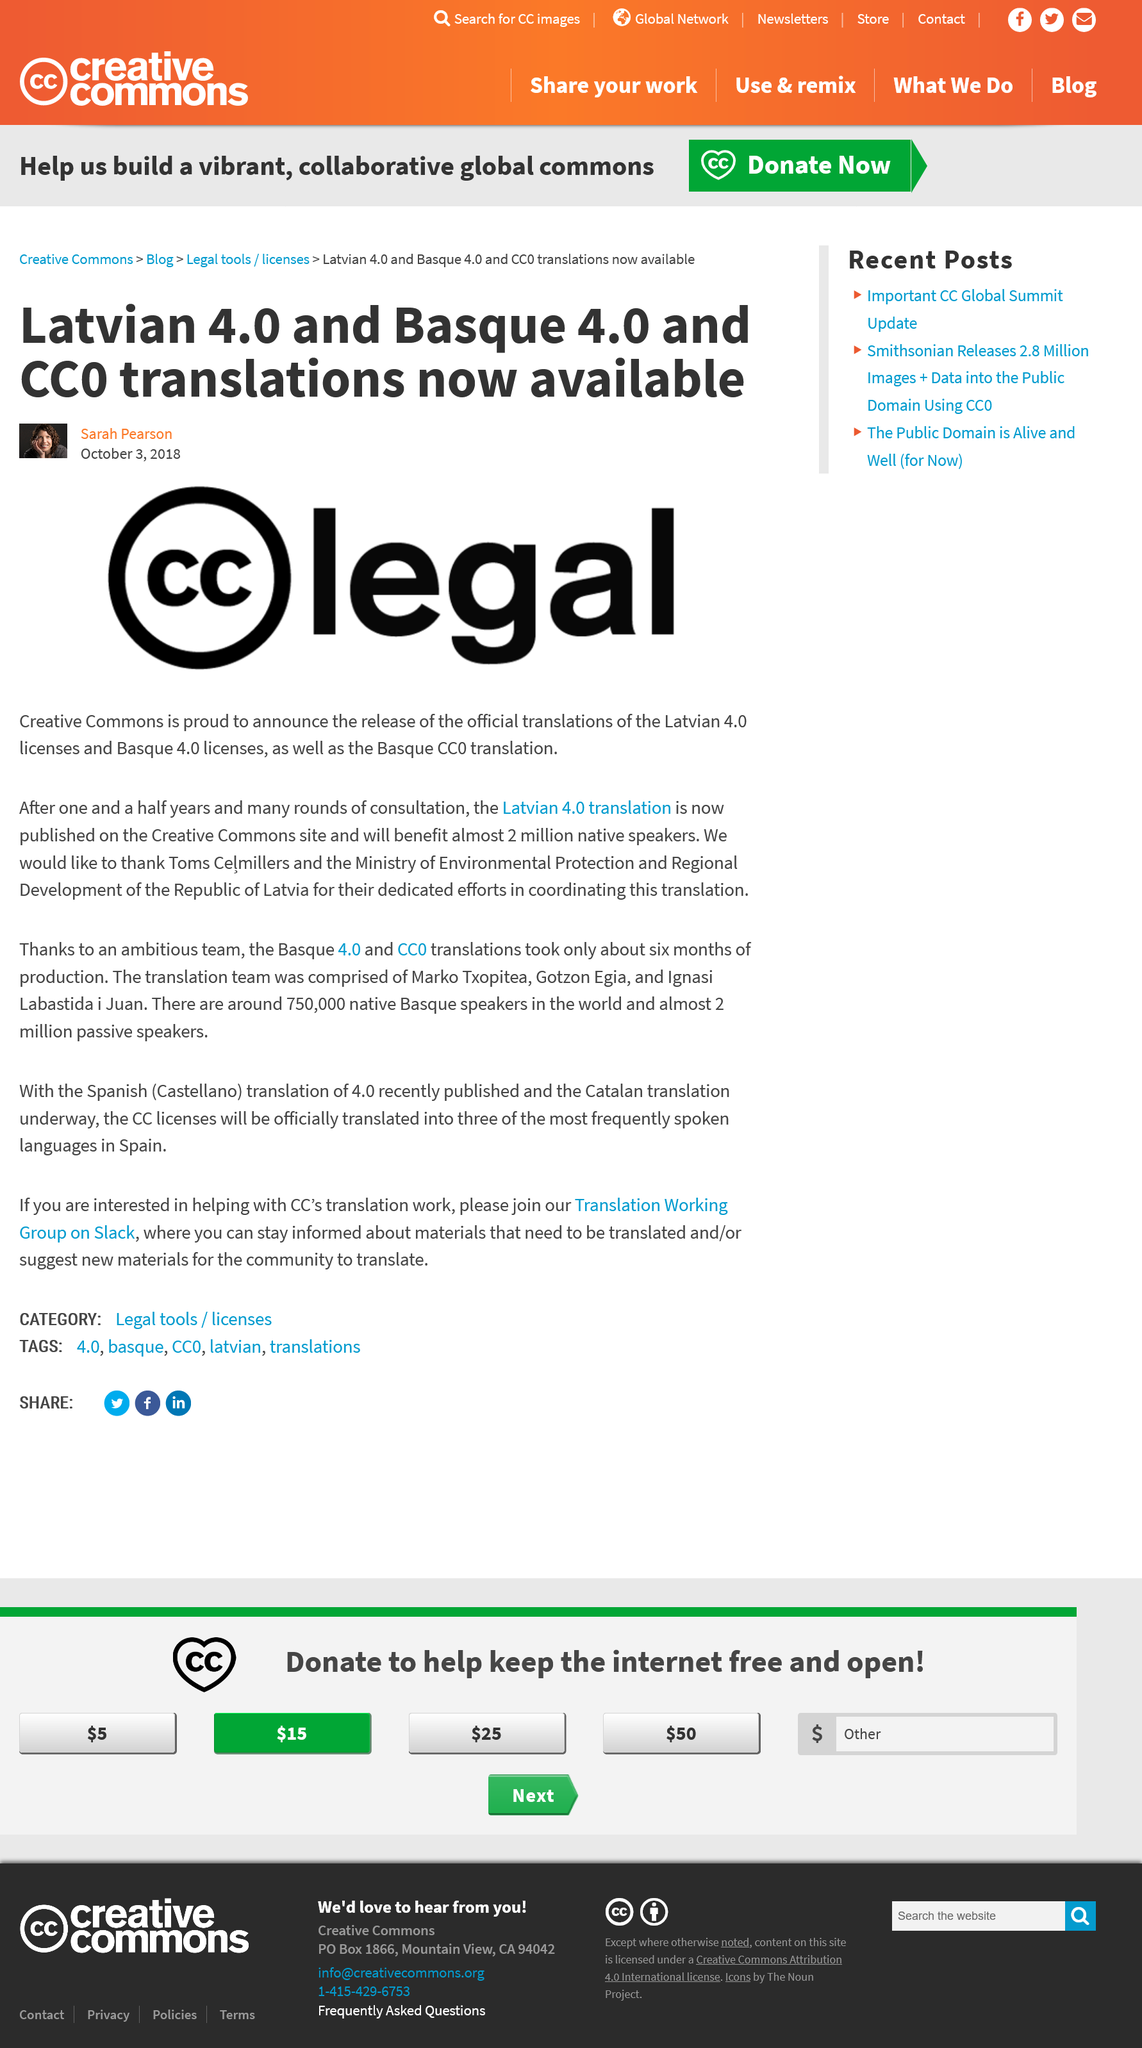Specify some key components in this picture. The CC legal logo represents Creative Commons, a nonprofit organization that promotes the use of shared and flexible copyright licenses to enable the creative reuse of content. Latvian 4.0 and Basque 4.0 translations, as well as CC0 translations, are currently available. The article was written by Sarah Pearson. 